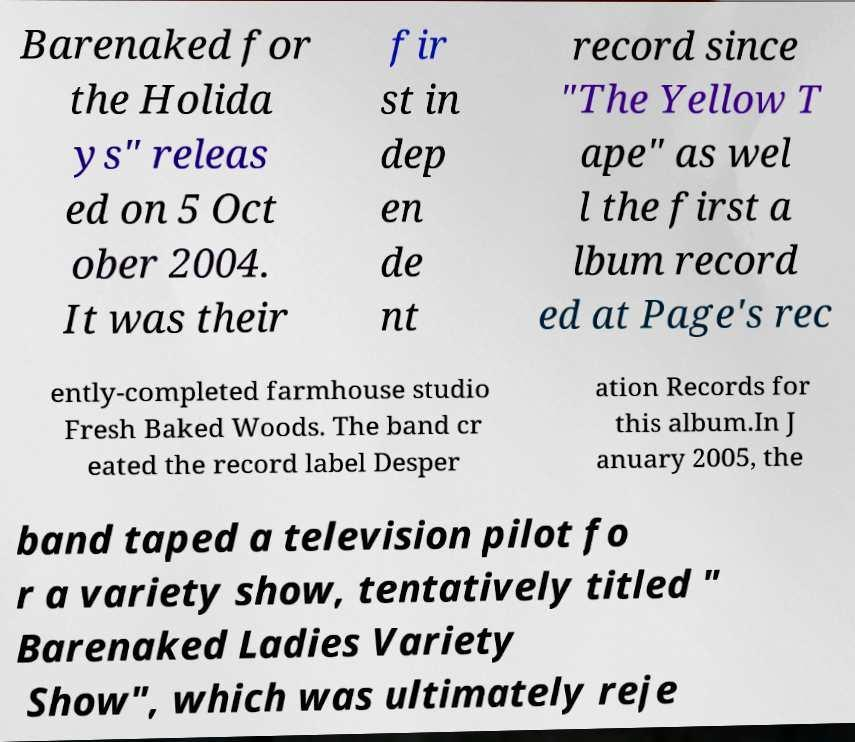Please read and relay the text visible in this image. What does it say? Barenaked for the Holida ys" releas ed on 5 Oct ober 2004. It was their fir st in dep en de nt record since "The Yellow T ape" as wel l the first a lbum record ed at Page's rec ently-completed farmhouse studio Fresh Baked Woods. The band cr eated the record label Desper ation Records for this album.In J anuary 2005, the band taped a television pilot fo r a variety show, tentatively titled " Barenaked Ladies Variety Show", which was ultimately reje 